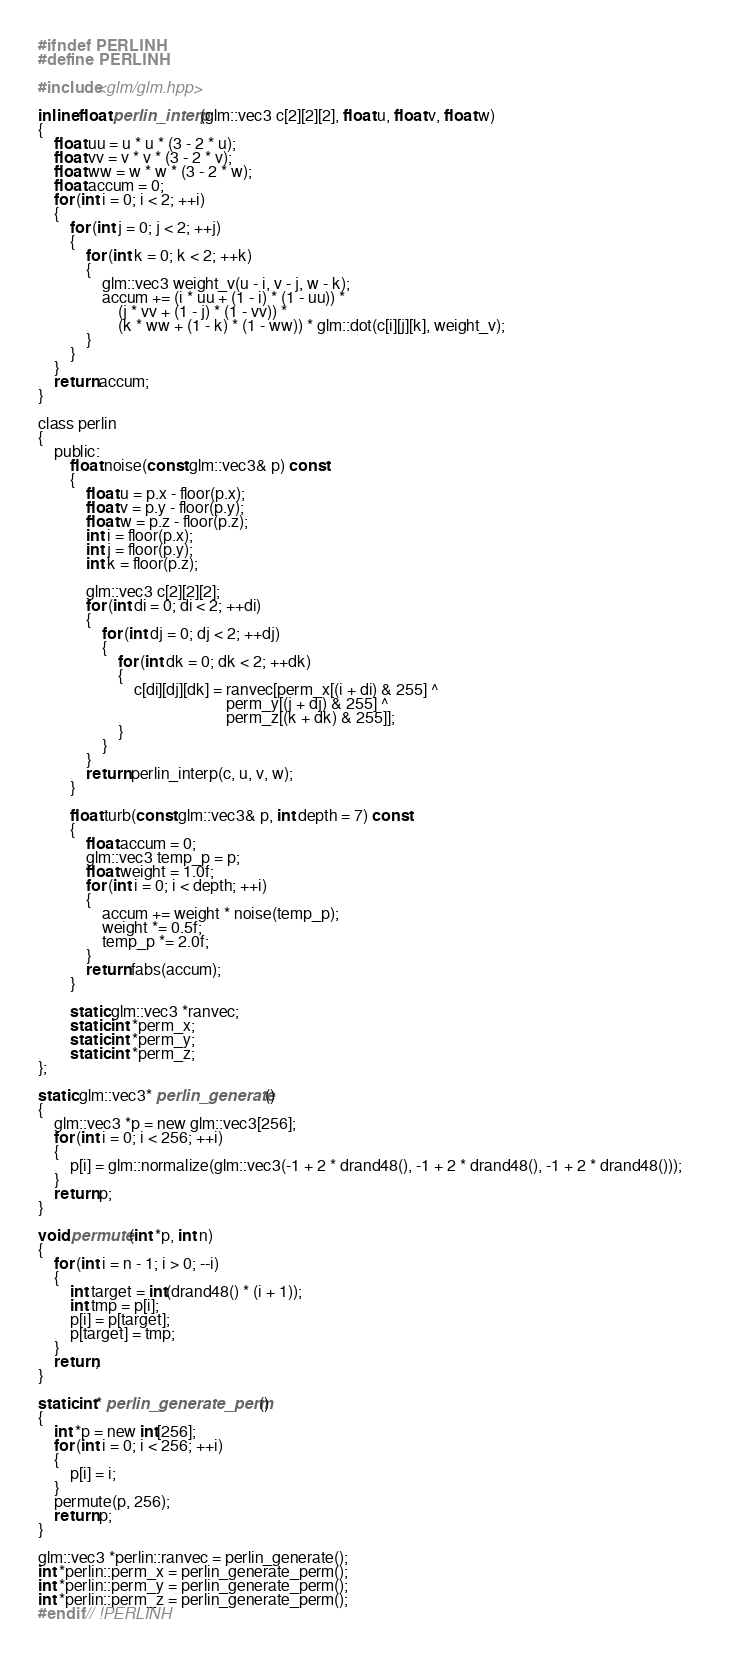<code> <loc_0><loc_0><loc_500><loc_500><_C_>#ifndef PERLINH
#define PERLINH

#include<glm/glm.hpp>

inline float perlin_interp(glm::vec3 c[2][2][2], float u, float v, float w)
{
	float uu = u * u * (3 - 2 * u);
	float vv = v * v * (3 - 2 * v);
	float ww = w * w * (3 - 2 * w);
	float accum = 0;
	for (int i = 0; i < 2; ++i)
	{
		for (int j = 0; j < 2; ++j)
		{
			for (int k = 0; k < 2; ++k)
			{
				glm::vec3 weight_v(u - i, v - j, w - k);
				accum += (i * uu + (1 - i) * (1 - uu)) *
					(j * vv + (1 - j) * (1 - vv)) *
					(k * ww + (1 - k) * (1 - ww)) * glm::dot(c[i][j][k], weight_v);
			}
		}
	}
	return accum;
}

class perlin
{
	public:
		float noise(const glm::vec3& p) const
		{
			float u = p.x - floor(p.x);
			float v = p.y - floor(p.y);
			float w = p.z - floor(p.z);			
			int i = floor(p.x);
			int j = floor(p.y);
			int k = floor(p.z);

			glm::vec3 c[2][2][2];
			for (int di = 0; di < 2; ++di)
			{
				for (int dj = 0; dj < 2; ++dj)
				{
					for (int dk = 0; dk < 2; ++dk)
					{
						c[di][dj][dk] = ranvec[perm_x[(i + di) & 255] ^ 
											   perm_y[(j + dj) & 255] ^ 
											   perm_z[(k + dk) & 255]];
					}
				}
			}
			return perlin_interp(c, u, v, w);
		}
		
		float turb(const glm::vec3& p, int depth = 7) const
		{
			float accum = 0;
			glm::vec3 temp_p = p;
			float weight = 1.0f;
			for (int i = 0; i < depth; ++i)
			{
				accum += weight * noise(temp_p);
				weight *= 0.5f;
				temp_p *= 2.0f;
			}
			return fabs(accum);
		}

		static glm::vec3 *ranvec;
		static int *perm_x;
		static int *perm_y;
		static int *perm_z;
};

static glm::vec3* perlin_generate()
{
	glm::vec3 *p = new glm::vec3[256];
	for (int i = 0; i < 256; ++i)
	{
		p[i] = glm::normalize(glm::vec3(-1 + 2 * drand48(), -1 + 2 * drand48(), -1 + 2 * drand48()));		
	}
	return p;
}

void permute(int *p, int n)
{
	for (int i = n - 1; i > 0; --i)
	{
		int target = int(drand48() * (i + 1));
		int tmp = p[i];
		p[i] = p[target];
		p[target] = tmp;
	}
	return;
}

static int* perlin_generate_perm()
{
	int *p = new int[256];
	for (int i = 0; i < 256; ++i)
	{
		p[i] = i;
	}
	permute(p, 256);
	return p;
}

glm::vec3 *perlin::ranvec = perlin_generate();
int *perlin::perm_x = perlin_generate_perm();
int *perlin::perm_y = perlin_generate_perm();
int *perlin::perm_z = perlin_generate_perm();
#endif // !PERLINH
</code> 